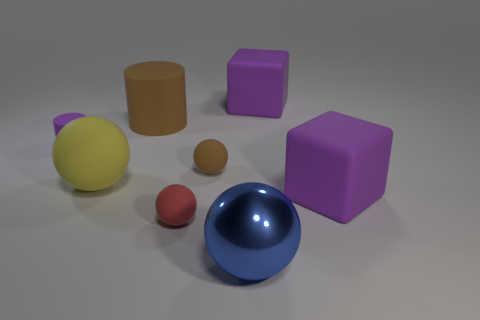Does the big shiny object have the same color as the tiny cylinder?
Your answer should be very brief. No. Is the shape of the big blue thing the same as the tiny thing that is in front of the small brown rubber sphere?
Keep it short and to the point. Yes. How many large metallic objects are in front of the blue ball?
Make the answer very short. 0. Are there any other spheres of the same size as the yellow matte ball?
Ensure brevity in your answer.  Yes. There is a big purple object in front of the large brown thing; is it the same shape as the small red matte object?
Provide a short and direct response. No. The metal ball has what color?
Ensure brevity in your answer.  Blue. The tiny object that is the same color as the large matte cylinder is what shape?
Ensure brevity in your answer.  Sphere. Are any tiny brown matte balls visible?
Ensure brevity in your answer.  Yes. What is the size of the yellow thing that is the same material as the large brown thing?
Keep it short and to the point. Large. What shape is the thing in front of the red object that is left of the brown matte object that is right of the brown cylinder?
Ensure brevity in your answer.  Sphere. 